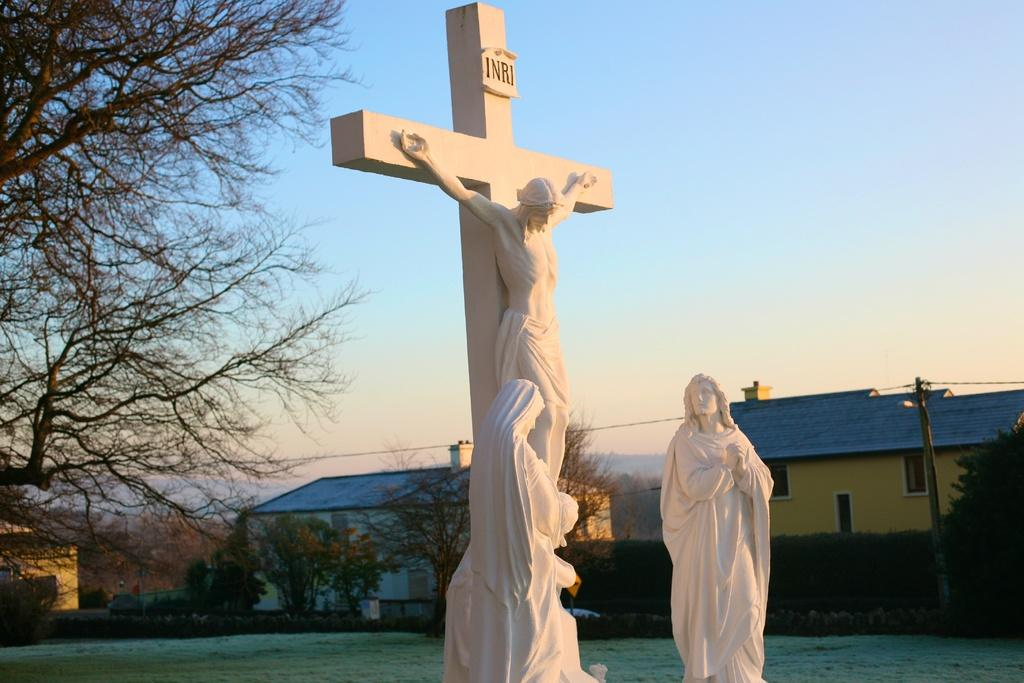<image>
Describe the image concisely. A life size white cross says INRI and Jesus is hanging on it. 